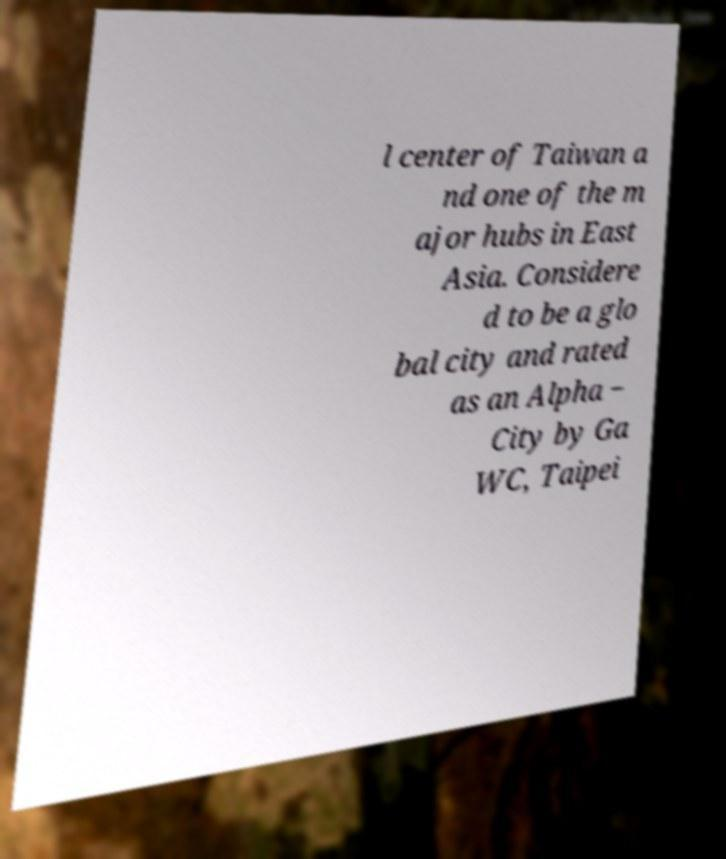Please identify and transcribe the text found in this image. l center of Taiwan a nd one of the m ajor hubs in East Asia. Considere d to be a glo bal city and rated as an Alpha − City by Ga WC, Taipei 